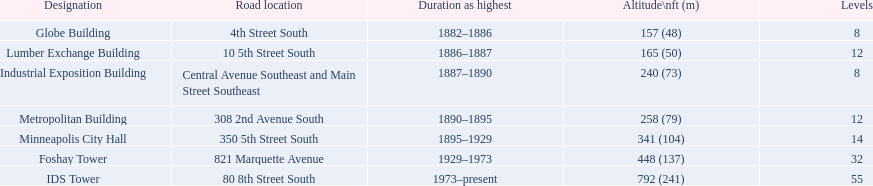What are the tallest buildings in minneapolis? Globe Building, Lumber Exchange Building, Industrial Exposition Building, Metropolitan Building, Minneapolis City Hall, Foshay Tower, IDS Tower. Which of those have 8 floors? Globe Building, Industrial Exposition Building. Of those, which is 240 ft tall? Industrial Exposition Building. 